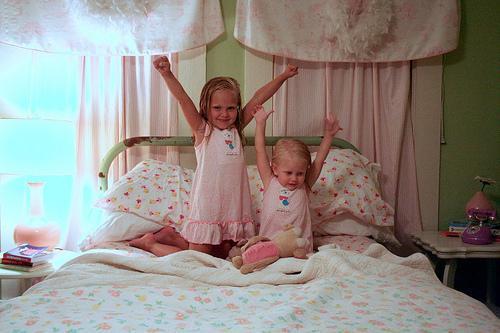How many children are there?
Give a very brief answer. 2. 